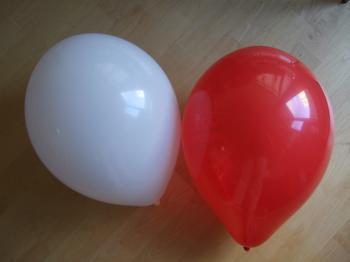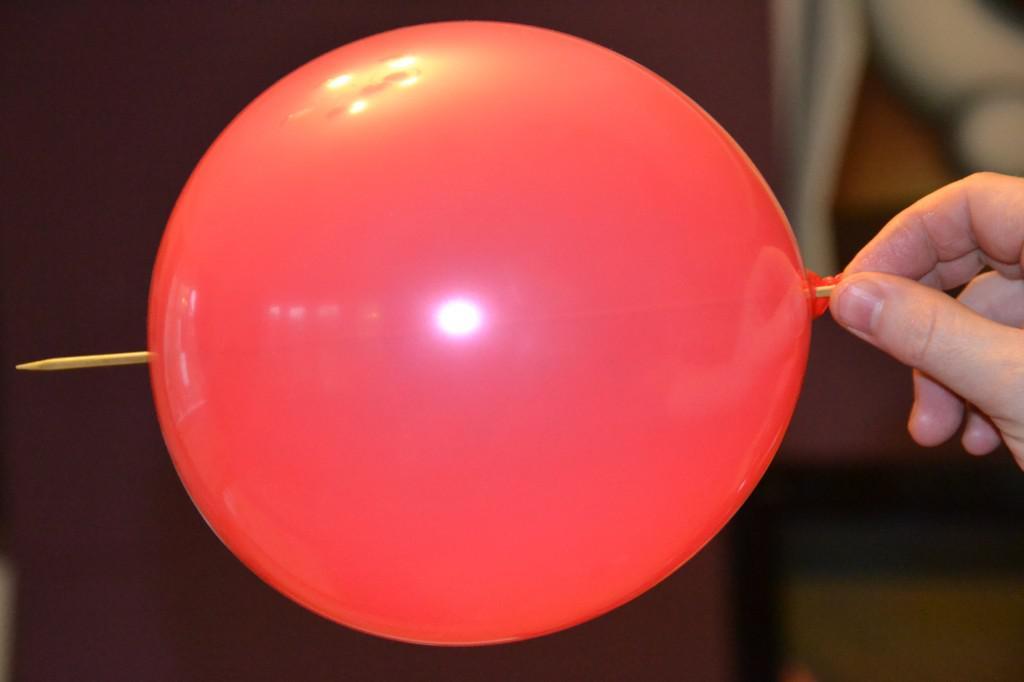The first image is the image on the left, the second image is the image on the right. Given the left and right images, does the statement "The left image contains at least two red balloons." hold true? Answer yes or no. No. The first image is the image on the left, the second image is the image on the right. Evaluate the accuracy of this statement regarding the images: "An image shows exactly two balloons of different colors, posed horizontally side-by-side.". Is it true? Answer yes or no. Yes. 